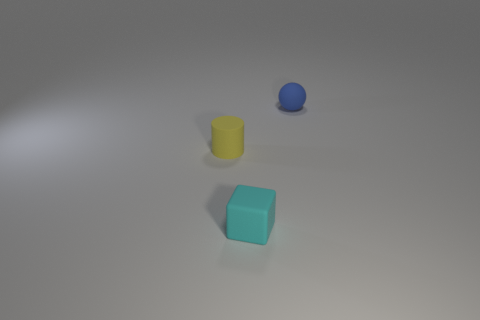Could the objects in the image serve a functional purpose? The objects might represent everyday items that have been simplified for the purpose of a visual composition. For instance, the yellow cylinder could be a cup or container, the cyan cube might be a toy block or a decoration piece, and the blue sphere could be a ball. However, without additional context, it's not possible to determine their exact function. 